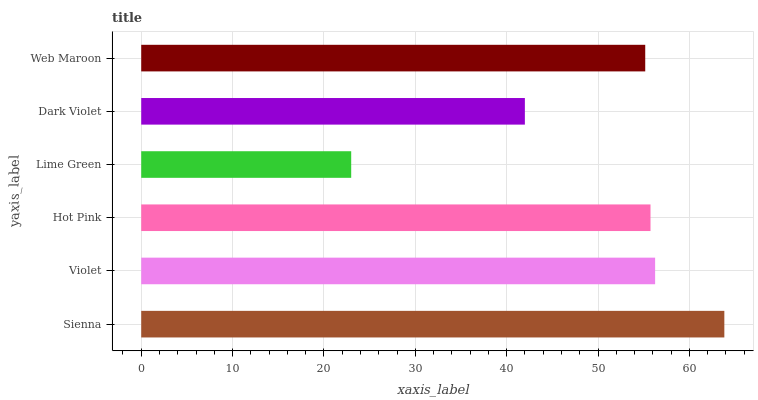Is Lime Green the minimum?
Answer yes or no. Yes. Is Sienna the maximum?
Answer yes or no. Yes. Is Violet the minimum?
Answer yes or no. No. Is Violet the maximum?
Answer yes or no. No. Is Sienna greater than Violet?
Answer yes or no. Yes. Is Violet less than Sienna?
Answer yes or no. Yes. Is Violet greater than Sienna?
Answer yes or no. No. Is Sienna less than Violet?
Answer yes or no. No. Is Hot Pink the high median?
Answer yes or no. Yes. Is Web Maroon the low median?
Answer yes or no. Yes. Is Sienna the high median?
Answer yes or no. No. Is Dark Violet the low median?
Answer yes or no. No. 